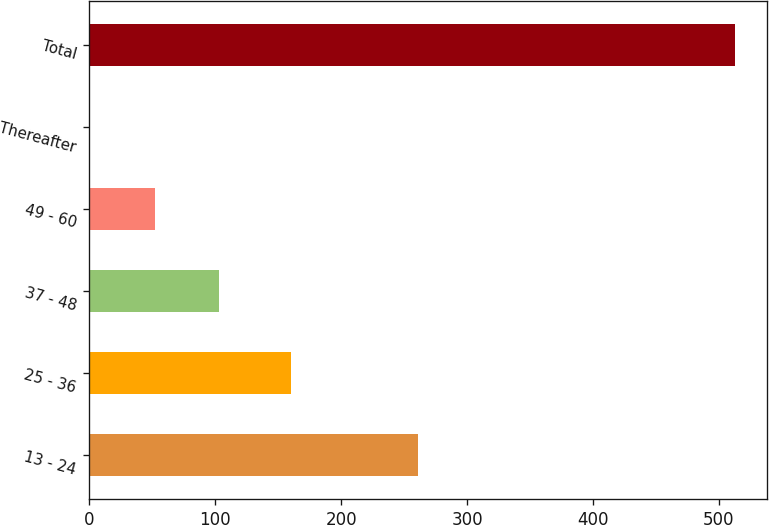<chart> <loc_0><loc_0><loc_500><loc_500><bar_chart><fcel>13 - 24<fcel>25 - 36<fcel>37 - 48<fcel>49 - 60<fcel>Thereafter<fcel>Total<nl><fcel>261.1<fcel>160.1<fcel>103.06<fcel>51.88<fcel>0.7<fcel>512.5<nl></chart> 